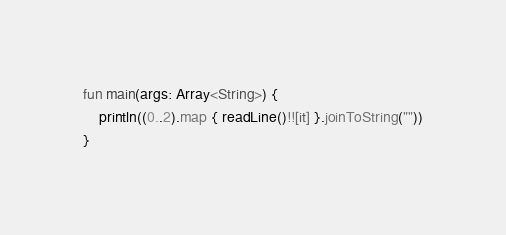Convert code to text. <code><loc_0><loc_0><loc_500><loc_500><_Kotlin_>fun main(args: Array<String>) {
    println((0..2).map { readLine()!![it] }.joinToString(""))
}
</code> 